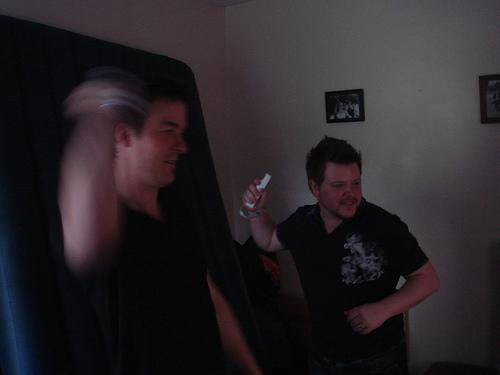How many men are there?
Give a very brief answer. 2. How many boys are shown?
Give a very brief answer. 2. How many people are in the photograph in the background?
Give a very brief answer. 2. 